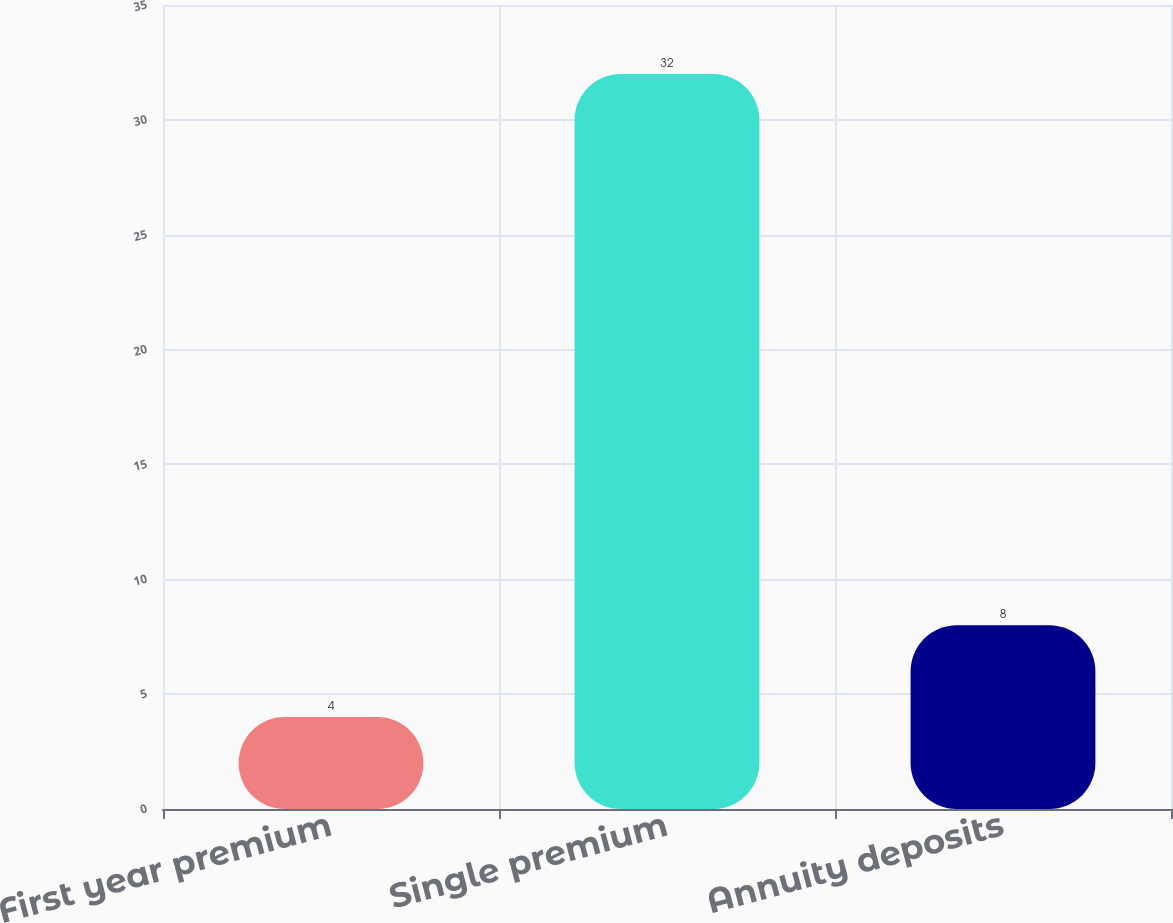<chart> <loc_0><loc_0><loc_500><loc_500><bar_chart><fcel>First year premium<fcel>Single premium<fcel>Annuity deposits<nl><fcel>4<fcel>32<fcel>8<nl></chart> 